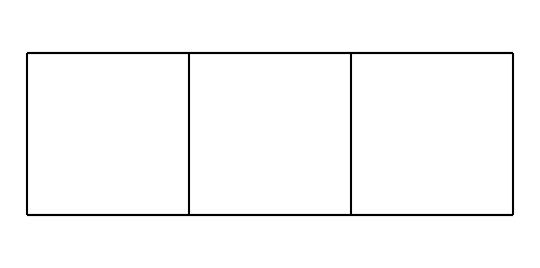What is the molecular formula of cubane? The molecular formula can be derived from counting the number of carbon and hydrogen atoms in the structure. Cubane consists of 8 carbon atoms and 8 hydrogen atoms.
Answer: C8H8 How many carbon atoms are present in the structure of cubane? By examining the structure, we note there are 8 vertices corresponding to carbon atoms in the cage-like configuration of cubane.
Answer: 8 What type of compound is cubane classified as? Cubane has a unique structure with a rigid cage-like arrangement, which classifies it as a cage compound within the category of hydrocarbons.
Answer: cage compound What is the bond type found between carbon atoms in cubane? The carbon atoms in cubane are bonded together by single covalent bonds, as indicated by the molecular structure showing no double or triple bonds present.
Answer: single covalent bonds How does the structure of cubane contribute to its high energy density? The compact and highly strained structure of cubane, with its saturated framework of carbon atoms, gives it high energy density, which is advantageous for applications like rocket fuels.
Answer: high energy density What is the primary use of cubane in the context of rocket fuels? Cubane is primarily used as a high-energy fuel component in rocket propellants due to its energy-releasing properties upon combustion.
Answer: high-energy rocket fuels 